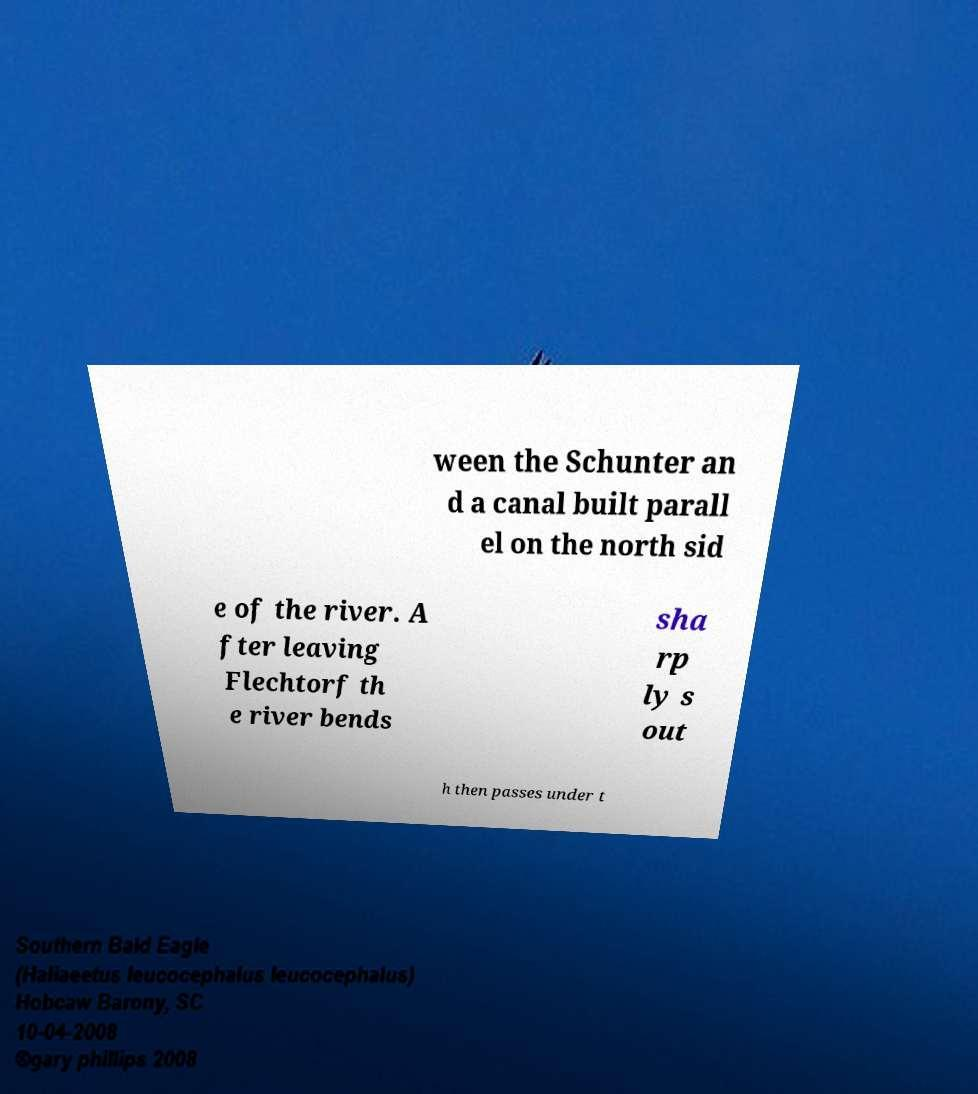Please read and relay the text visible in this image. What does it say? ween the Schunter an d a canal built parall el on the north sid e of the river. A fter leaving Flechtorf th e river bends sha rp ly s out h then passes under t 